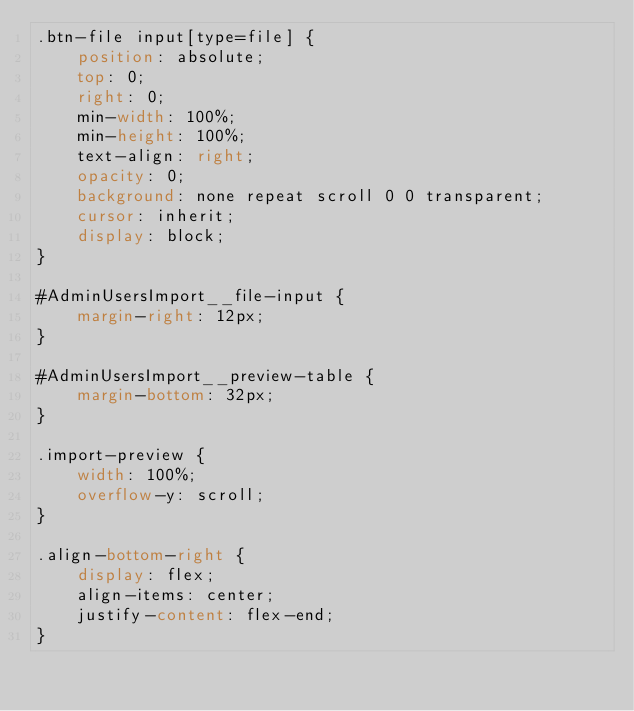Convert code to text. <code><loc_0><loc_0><loc_500><loc_500><_CSS_>.btn-file input[type=file] {
    position: absolute;
    top: 0;
    right: 0;
    min-width: 100%;
    min-height: 100%;
    text-align: right;
    opacity: 0;
    background: none repeat scroll 0 0 transparent;
    cursor: inherit;
    display: block;
}

#AdminUsersImport__file-input {
    margin-right: 12px;
}

#AdminUsersImport__preview-table {
    margin-bottom: 32px;
}

.import-preview {
    width: 100%;
    overflow-y: scroll;
}

.align-bottom-right {
    display: flex;
    align-items: center;
    justify-content: flex-end;
}</code> 